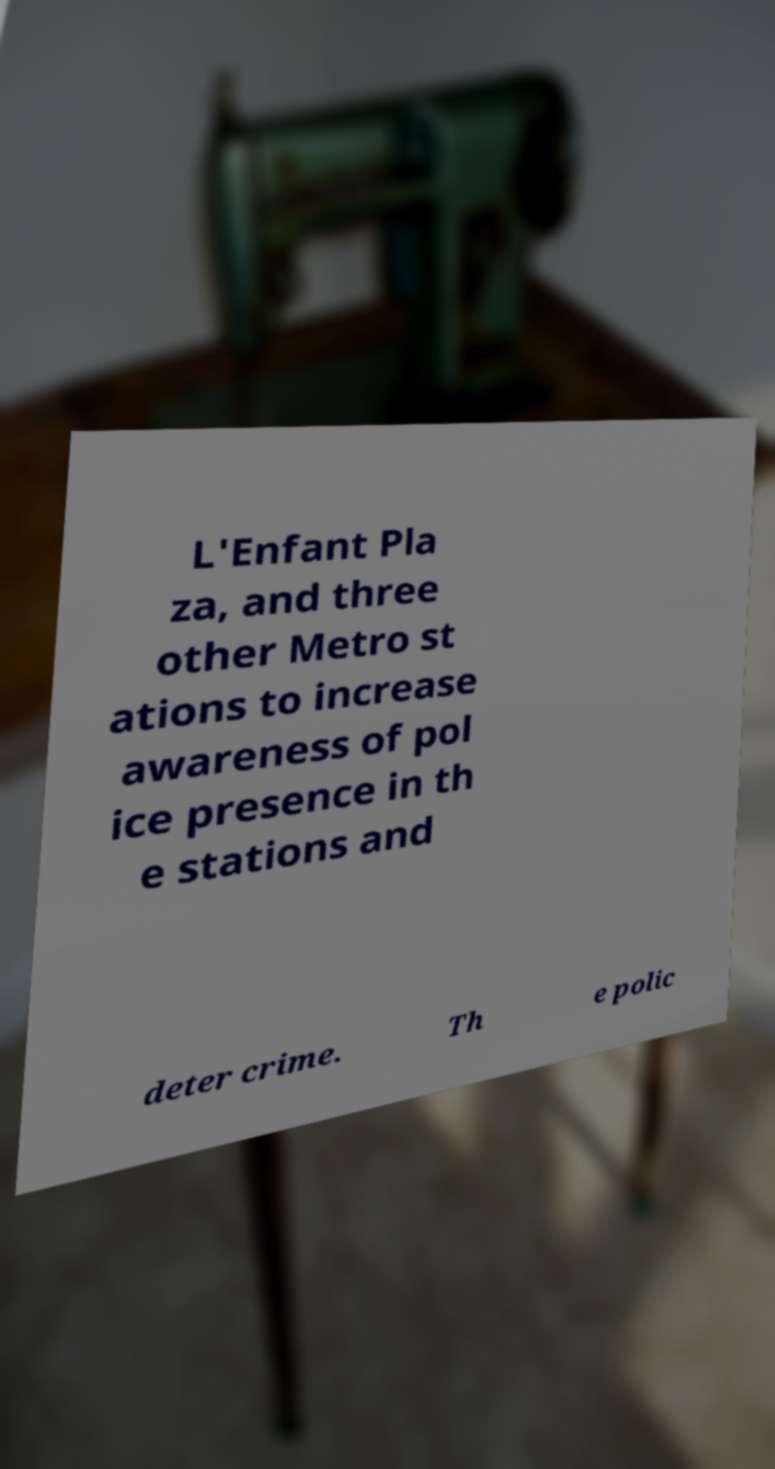Can you accurately transcribe the text from the provided image for me? L'Enfant Pla za, and three other Metro st ations to increase awareness of pol ice presence in th e stations and deter crime. Th e polic 